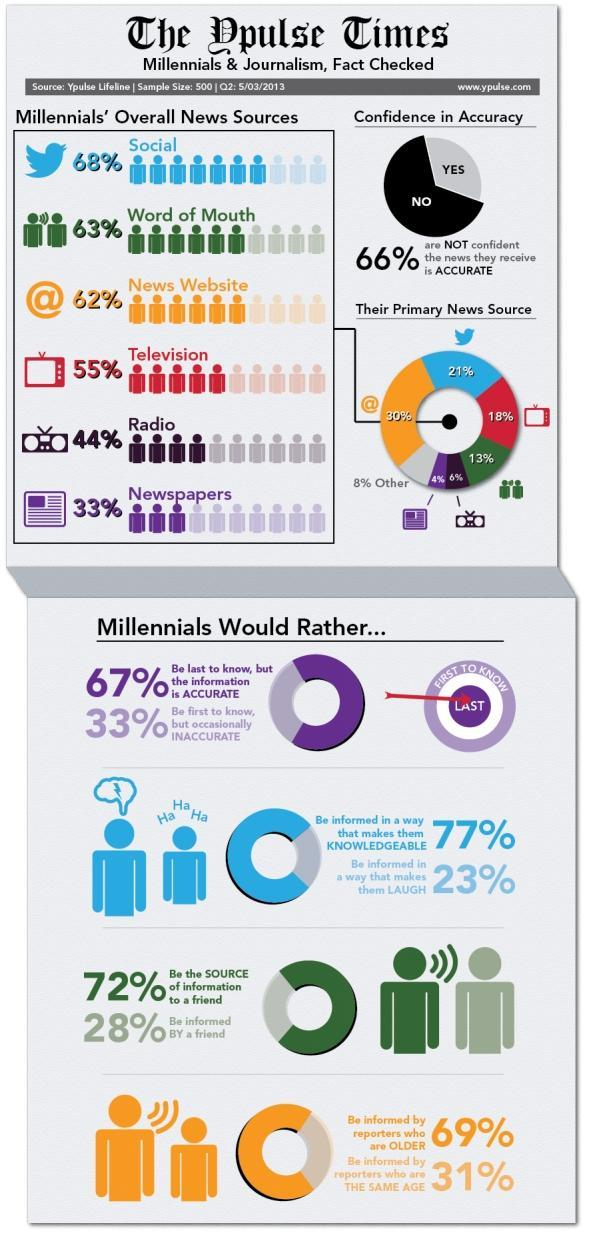Which type of information is preferred by majority of millennials - inaccurate, funny or knowledgeable?
Answer the question with a short phrase. knowledgeable What percent of millennials use social networks as their primary news source? 21% What percent of millennials use television as their primary news source? 18% What is used by 30% of millennials as their primary news source? News website 